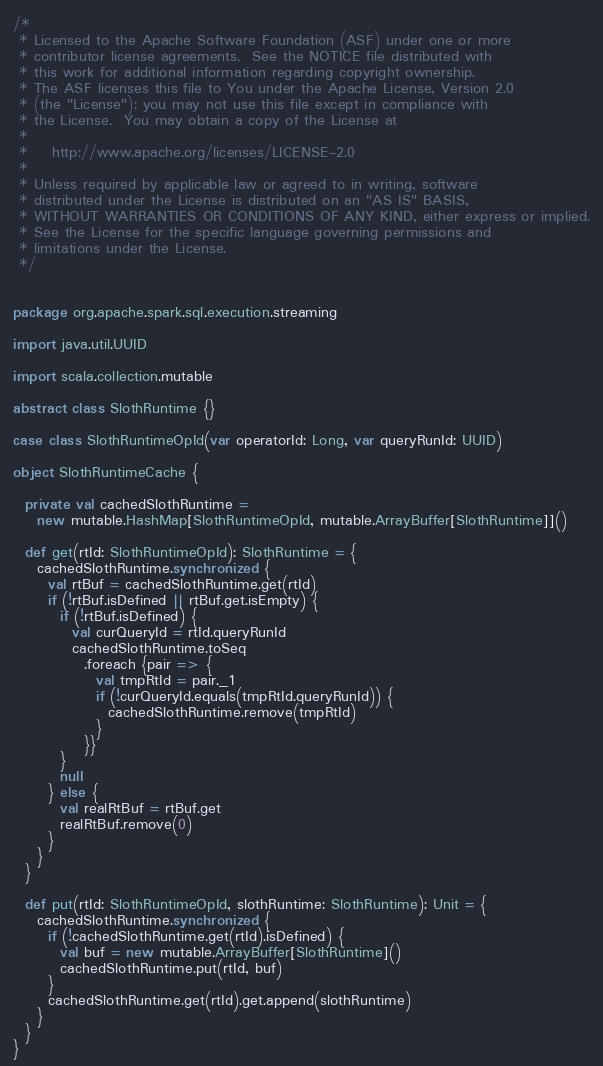<code> <loc_0><loc_0><loc_500><loc_500><_Scala_>/*
 * Licensed to the Apache Software Foundation (ASF) under one or more
 * contributor license agreements.  See the NOTICE file distributed with
 * this work for additional information regarding copyright ownership.
 * The ASF licenses this file to You under the Apache License, Version 2.0
 * (the "License"); you may not use this file except in compliance with
 * the License.  You may obtain a copy of the License at
 *
 *    http://www.apache.org/licenses/LICENSE-2.0
 *
 * Unless required by applicable law or agreed to in writing, software
 * distributed under the License is distributed on an "AS IS" BASIS,
 * WITHOUT WARRANTIES OR CONDITIONS OF ANY KIND, either express or implied.
 * See the License for the specific language governing permissions and
 * limitations under the License.
 */


package org.apache.spark.sql.execution.streaming

import java.util.UUID

import scala.collection.mutable

abstract class SlothRuntime {}

case class SlothRuntimeOpId(var operatorId: Long, var queryRunId: UUID)

object SlothRuntimeCache {

  private val cachedSlothRuntime =
    new mutable.HashMap[SlothRuntimeOpId, mutable.ArrayBuffer[SlothRuntime]]()

  def get(rtId: SlothRuntimeOpId): SlothRuntime = {
    cachedSlothRuntime.synchronized {
      val rtBuf = cachedSlothRuntime.get(rtId)
      if (!rtBuf.isDefined || rtBuf.get.isEmpty) {
        if (!rtBuf.isDefined) {
          val curQueryId = rtId.queryRunId
          cachedSlothRuntime.toSeq
            .foreach {pair => {
              val tmpRtId = pair._1
              if (!curQueryId.equals(tmpRtId.queryRunId)) {
                cachedSlothRuntime.remove(tmpRtId)
              }
            }}
        }
        null
      } else {
        val realRtBuf = rtBuf.get
        realRtBuf.remove(0)
      }
    }
  }

  def put(rtId: SlothRuntimeOpId, slothRuntime: SlothRuntime): Unit = {
    cachedSlothRuntime.synchronized {
      if (!cachedSlothRuntime.get(rtId).isDefined) {
        val buf = new mutable.ArrayBuffer[SlothRuntime]()
        cachedSlothRuntime.put(rtId, buf)
      }
      cachedSlothRuntime.get(rtId).get.append(slothRuntime)
    }
  }
}
</code> 